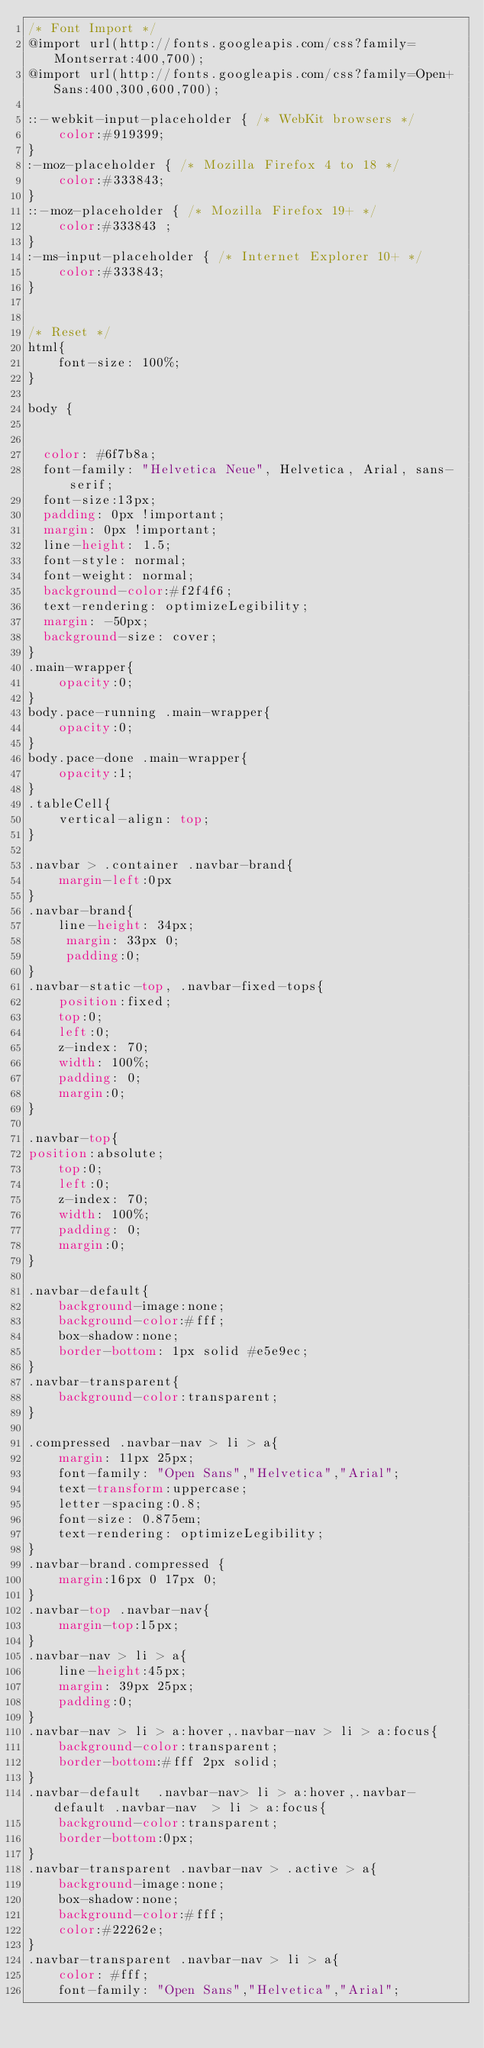Convert code to text. <code><loc_0><loc_0><loc_500><loc_500><_CSS_>/* Font Import */
@import url(http://fonts.googleapis.com/css?family=Montserrat:400,700);
@import url(http://fonts.googleapis.com/css?family=Open+Sans:400,300,600,700);

::-webkit-input-placeholder { /* WebKit browsers */
    color:#919399;
}
:-moz-placeholder { /* Mozilla Firefox 4 to 18 */
    color:#333843;
}
::-moz-placeholder { /* Mozilla Firefox 19+ */
    color:#333843 ;
}
:-ms-input-placeholder { /* Internet Explorer 10+ */
    color:#333843;
}


/* Reset */
html{
	font-size: 100%;
}

body { 


  color: #6f7b8a; 
  font-family: "Helvetica Neue", Helvetica, Arial, sans-serif;
  font-size:13px;
  padding: 0px !important;
  margin: 0px !important;
  line-height: 1.5;
  font-style: normal;	
  font-weight: normal;
  background-color:#f2f4f6;  
  text-rendering: optimizeLegibility;
  margin: -50px;
  background-size: cover;
}
.main-wrapper{
	opacity:0;
}
body.pace-running .main-wrapper{
	opacity:0;
}
body.pace-done .main-wrapper{
	opacity:1;
}
.tableCell{
	vertical-align: top;
}

.navbar > .container .navbar-brand{
	margin-left:0px
}
.navbar-brand{
	line-height: 34px;
	 margin: 33px 0;
	 padding:0;
}
.navbar-static-top, .navbar-fixed-tops{
	position:fixed;
	top:0;
	left:0;
	z-index: 70;
	width: 100%;
	padding: 0;
	margin:0;
}

.navbar-top{
position:absolute;
	top:0;
	left:0;
	z-index: 70;
	width: 100%;
	padding: 0;
	margin:0;
}

.navbar-default{
	background-image:none;
	background-color:#fff;
	box-shadow:none;
	border-bottom: 1px solid #e5e9ec;
}
.navbar-transparent{
	background-color:transparent;
}

.compressed .navbar-nav > li > a{
	margin: 11px 25px;
	font-family: "Open Sans","Helvetica","Arial";
	text-transform:uppercase;
	letter-spacing:0.8;
	font-size: 0.875em;
	text-rendering: optimizeLegibility;
}
.navbar-brand.compressed {
	margin:16px 0 17px 0;
}
.navbar-top .navbar-nav{
	margin-top:15px;
}
.navbar-nav > li > a{
	line-height:45px;
	margin: 39px 25px;
	padding:0;
}
.navbar-nav > li > a:hover,.navbar-nav > li > a:focus{
	background-color:transparent;
	border-bottom:#fff 2px solid;
}
.navbar-default  .navbar-nav> li > a:hover,.navbar-default .navbar-nav  > li > a:focus{
	background-color:transparent;
	border-bottom:0px;
}
.navbar-transparent .navbar-nav > .active > a{
	background-image:none;
	box-shadow:none;
	background-color:#fff;
	color:#22262e;
}
.navbar-transparent .navbar-nav > li > a{
	color: #fff;
	font-family: "Open Sans","Helvetica","Arial";</code> 